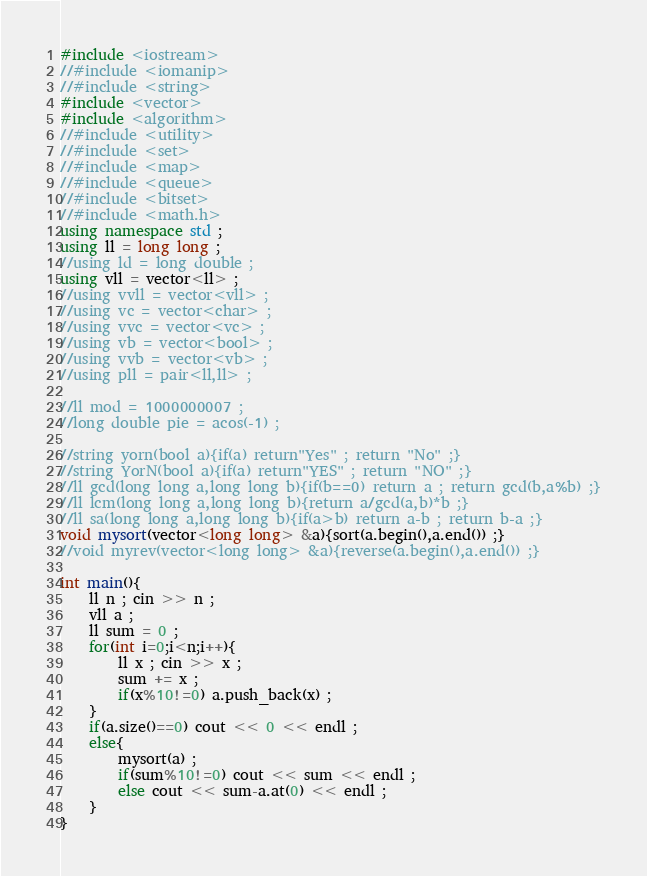Convert code to text. <code><loc_0><loc_0><loc_500><loc_500><_C++_>#include <iostream>
//#include <iomanip>
//#include <string>
#include <vector>
#include <algorithm>
//#include <utility>
//#include <set>
//#include <map>
//#include <queue>
//#include <bitset>
//#include <math.h>
using namespace std ;
using ll = long long ;
//using ld = long double ;
using vll = vector<ll> ;
//using vvll = vector<vll> ;
//using vc = vector<char> ;
//using vvc = vector<vc> ;
//using vb = vector<bool> ;
//using vvb = vector<vb> ;
//using pll = pair<ll,ll> ;

//ll mod = 1000000007 ;
//long double pie = acos(-1) ;

//string yorn(bool a){if(a) return"Yes" ; return "No" ;}
//string YorN(bool a){if(a) return"YES" ; return "NO" ;}
//ll gcd(long long a,long long b){if(b==0) return a ; return gcd(b,a%b) ;}
//ll lcm(long long a,long long b){return a/gcd(a,b)*b ;}
//ll sa(long long a,long long b){if(a>b) return a-b ; return b-a ;}
void mysort(vector<long long> &a){sort(a.begin(),a.end()) ;}
//void myrev(vector<long long> &a){reverse(a.begin(),a.end()) ;}

int main(){
	ll n ; cin >> n ;
	vll a ;
	ll sum = 0 ;
	for(int i=0;i<n;i++){
		ll x ; cin >> x ;
		sum += x ;
		if(x%10!=0) a.push_back(x) ;
	}
	if(a.size()==0) cout << 0 << endl ;
	else{
		mysort(a) ;
		if(sum%10!=0) cout << sum << endl ;
		else cout << sum-a.at(0) << endl ;
	}
}
</code> 